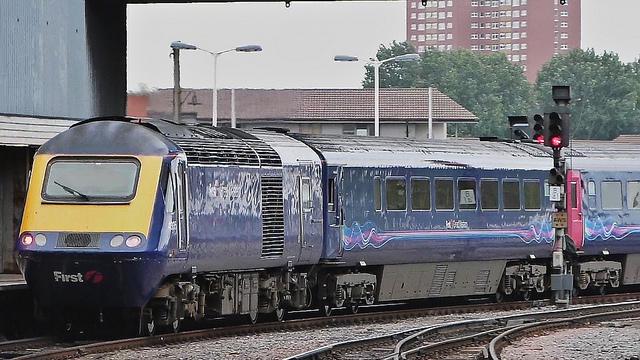What is hanging on the front of the middle train?
Quick response, please. Door. Is the building behind the train tall?
Write a very short answer. Yes. Is this an urban area?
Be succinct. Yes. Is the train currently in a city?
Give a very brief answer. Yes. What kind of building is in the background?
Give a very brief answer. Skyscraper. Is this considered a passenger train?
Short answer required. Yes. What color is the traffic light?
Keep it brief. Red. How is this train powered?
Keep it brief. Electric. Is this a passenger train?
Quick response, please. Yes. What numbers are on the train?
Quick response, please. 0. Is the train expensive?
Write a very short answer. Yes. What color is the building to the right?
Quick response, please. Red. What color is the front of the train?
Answer briefly. Yellow. 